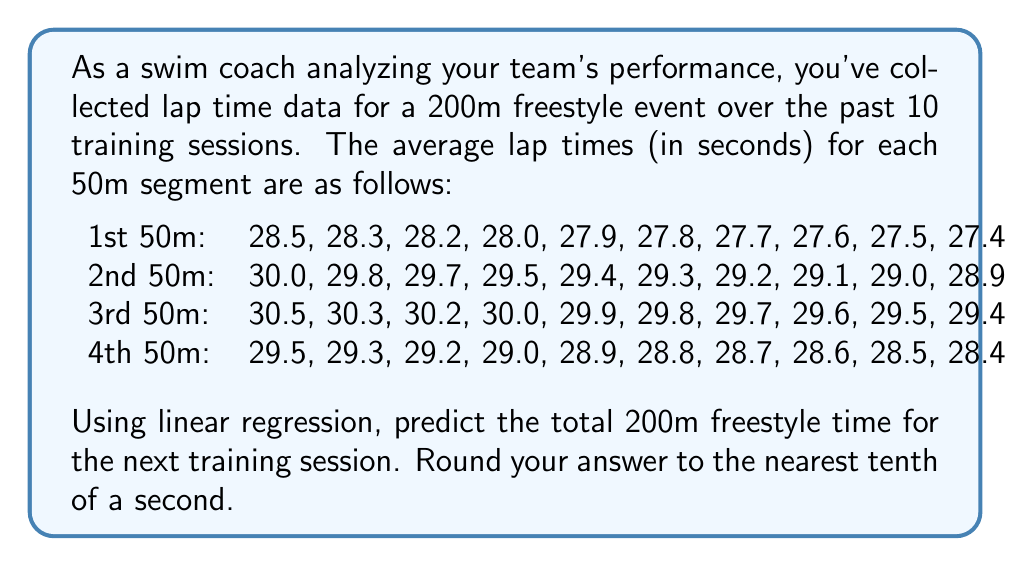Give your solution to this math problem. To solve this problem, we'll use linear regression to predict the lap times for each 50m segment, then sum these predictions to get the total 200m time.

1. For each 50m segment, we'll calculate the slope (m) and y-intercept (b) of the linear regression line.

2. The formula for the slope is:
   $$m = \frac{n\sum xy - \sum x \sum y}{n\sum x^2 - (\sum x)^2}$$
   where n is the number of data points, x is the session number, and y is the lap time.

3. The y-intercept is calculated using:
   $$b = \bar{y} - m\bar{x}$$
   where $\bar{x}$ and $\bar{y}$ are the means of x and y respectively.

4. For each segment:

   1st 50m:
   $m_1 = -0.122$, $b_1 = 28.689$
   Prediction for session 11: $y = -0.122 * 11 + 28.689 = 27.347$

   2nd 50m:
   $m_2 = -0.122$, $b_2 = 30.189$
   Prediction for session 11: $y = -0.122 * 11 + 30.189 = 28.847$

   3rd 50m:
   $m_3 = -0.122$, $b_3 = 30.689$
   Prediction for session 11: $y = -0.122 * 11 + 30.689 = 29.347$

   4th 50m:
   $m_4 = -0.122$, $b_4 = 29.689$
   Prediction for session 11: $y = -0.122 * 11 + 29.689 = 28.347$

5. Sum the predicted times for each 50m segment:
   $27.347 + 28.847 + 29.347 + 28.347 = 113.888$

6. Round to the nearest tenth:
   $113.888 \approx 113.9$ seconds
Answer: 113.9 seconds 